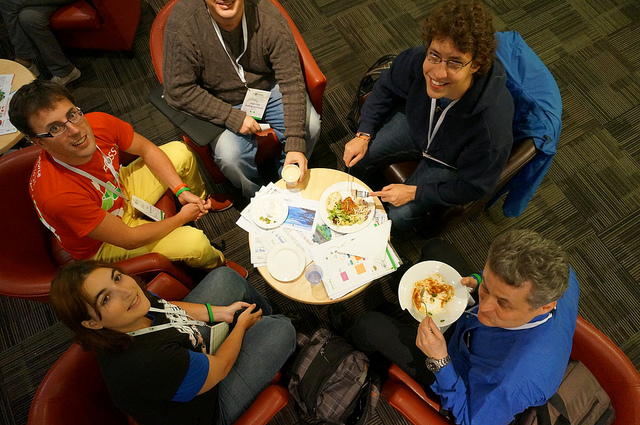Read and extract the text from this image. SS 